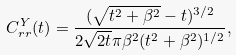<formula> <loc_0><loc_0><loc_500><loc_500>C _ { r r } ^ { Y } ( t ) = \frac { ( \sqrt { t ^ { 2 } + \beta ^ { 2 } } - t ) ^ { 3 / 2 } } { 2 \sqrt { 2 t } \pi \beta ^ { 2 } ( t ^ { 2 } + \beta ^ { 2 } ) ^ { 1 / 2 } } ,</formula> 